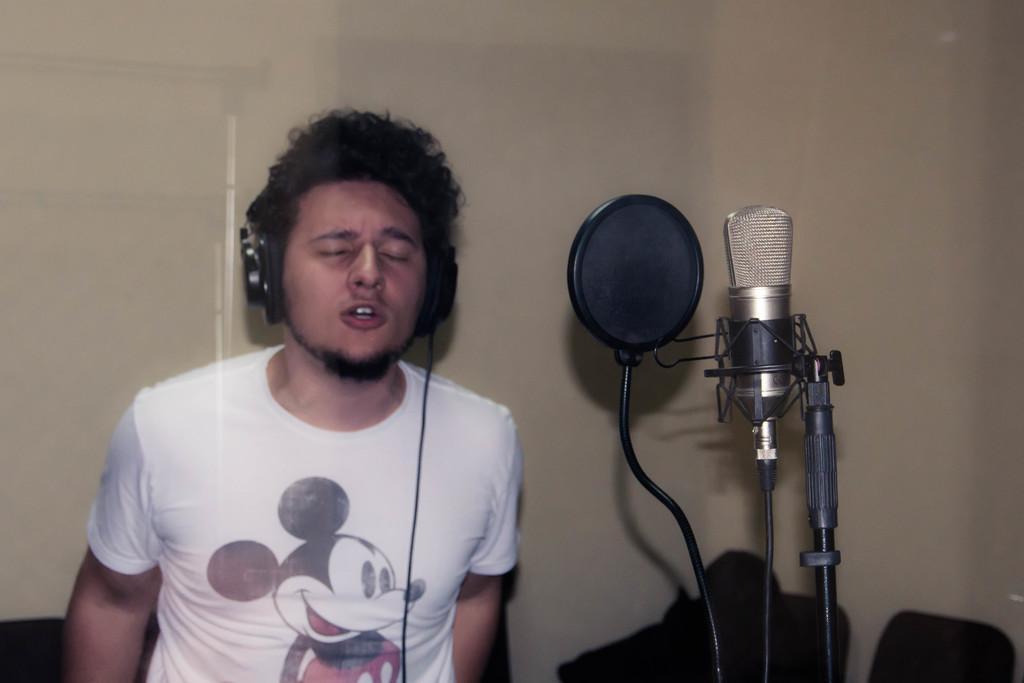Describe this image in one or two sentences. In the center of the image we can see person standing and wearing headset. On the right side of the image we can see mic. In the background there is wall. 